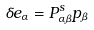Convert formula to latex. <formula><loc_0><loc_0><loc_500><loc_500>\delta e _ { \alpha } = P ^ { s } _ { \alpha \beta } p _ { \beta }</formula> 